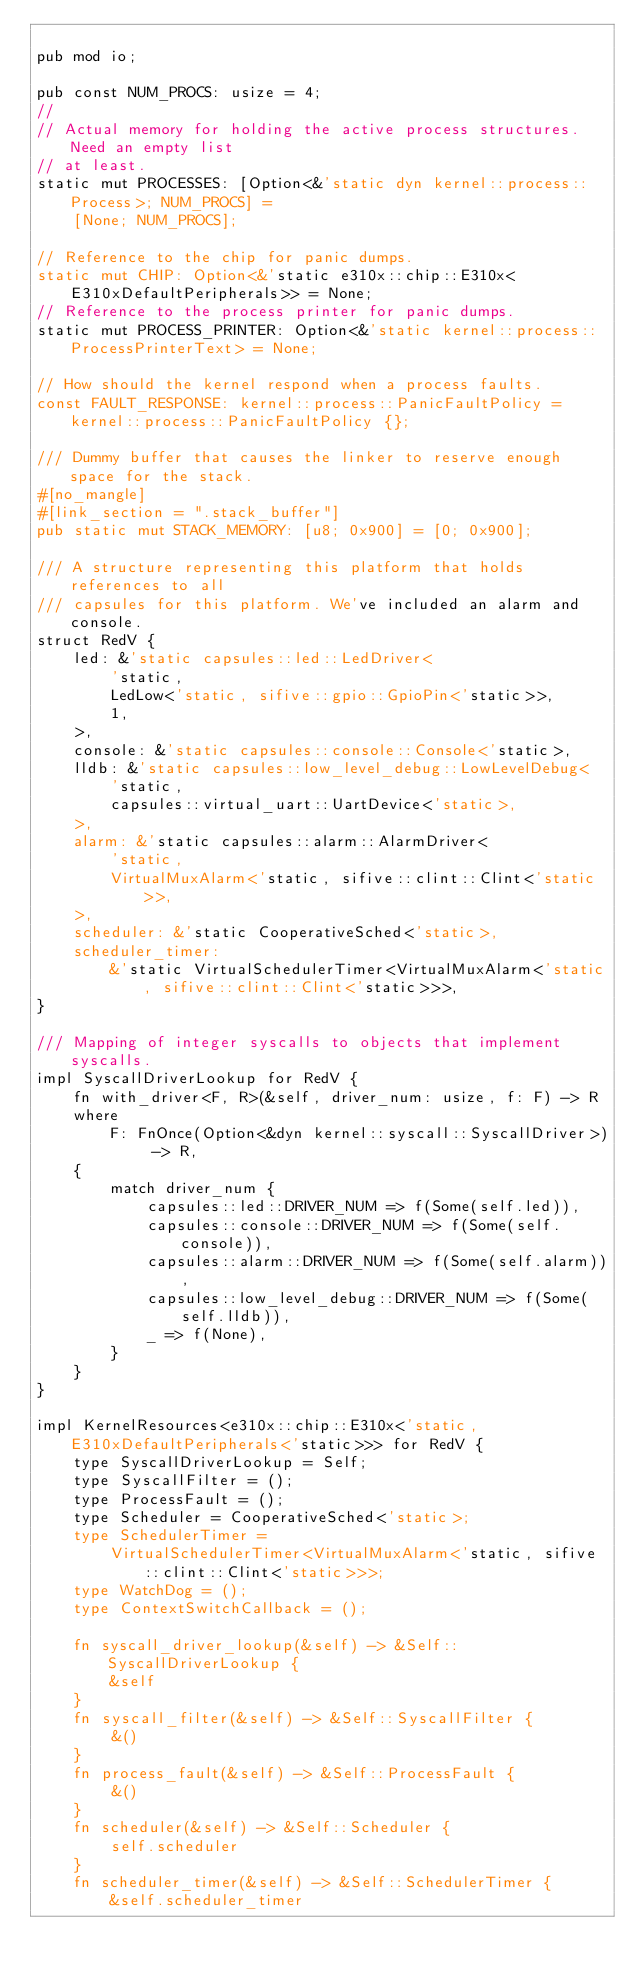<code> <loc_0><loc_0><loc_500><loc_500><_Rust_>
pub mod io;

pub const NUM_PROCS: usize = 4;
//
// Actual memory for holding the active process structures. Need an empty list
// at least.
static mut PROCESSES: [Option<&'static dyn kernel::process::Process>; NUM_PROCS] =
    [None; NUM_PROCS];

// Reference to the chip for panic dumps.
static mut CHIP: Option<&'static e310x::chip::E310x<E310xDefaultPeripherals>> = None;
// Reference to the process printer for panic dumps.
static mut PROCESS_PRINTER: Option<&'static kernel::process::ProcessPrinterText> = None;

// How should the kernel respond when a process faults.
const FAULT_RESPONSE: kernel::process::PanicFaultPolicy = kernel::process::PanicFaultPolicy {};

/// Dummy buffer that causes the linker to reserve enough space for the stack.
#[no_mangle]
#[link_section = ".stack_buffer"]
pub static mut STACK_MEMORY: [u8; 0x900] = [0; 0x900];

/// A structure representing this platform that holds references to all
/// capsules for this platform. We've included an alarm and console.
struct RedV {
    led: &'static capsules::led::LedDriver<
        'static,
        LedLow<'static, sifive::gpio::GpioPin<'static>>,
        1,
    >,
    console: &'static capsules::console::Console<'static>,
    lldb: &'static capsules::low_level_debug::LowLevelDebug<
        'static,
        capsules::virtual_uart::UartDevice<'static>,
    >,
    alarm: &'static capsules::alarm::AlarmDriver<
        'static,
        VirtualMuxAlarm<'static, sifive::clint::Clint<'static>>,
    >,
    scheduler: &'static CooperativeSched<'static>,
    scheduler_timer:
        &'static VirtualSchedulerTimer<VirtualMuxAlarm<'static, sifive::clint::Clint<'static>>>,
}

/// Mapping of integer syscalls to objects that implement syscalls.
impl SyscallDriverLookup for RedV {
    fn with_driver<F, R>(&self, driver_num: usize, f: F) -> R
    where
        F: FnOnce(Option<&dyn kernel::syscall::SyscallDriver>) -> R,
    {
        match driver_num {
            capsules::led::DRIVER_NUM => f(Some(self.led)),
            capsules::console::DRIVER_NUM => f(Some(self.console)),
            capsules::alarm::DRIVER_NUM => f(Some(self.alarm)),
            capsules::low_level_debug::DRIVER_NUM => f(Some(self.lldb)),
            _ => f(None),
        }
    }
}

impl KernelResources<e310x::chip::E310x<'static, E310xDefaultPeripherals<'static>>> for RedV {
    type SyscallDriverLookup = Self;
    type SyscallFilter = ();
    type ProcessFault = ();
    type Scheduler = CooperativeSched<'static>;
    type SchedulerTimer =
        VirtualSchedulerTimer<VirtualMuxAlarm<'static, sifive::clint::Clint<'static>>>;
    type WatchDog = ();
    type ContextSwitchCallback = ();

    fn syscall_driver_lookup(&self) -> &Self::SyscallDriverLookup {
        &self
    }
    fn syscall_filter(&self) -> &Self::SyscallFilter {
        &()
    }
    fn process_fault(&self) -> &Self::ProcessFault {
        &()
    }
    fn scheduler(&self) -> &Self::Scheduler {
        self.scheduler
    }
    fn scheduler_timer(&self) -> &Self::SchedulerTimer {
        &self.scheduler_timer</code> 